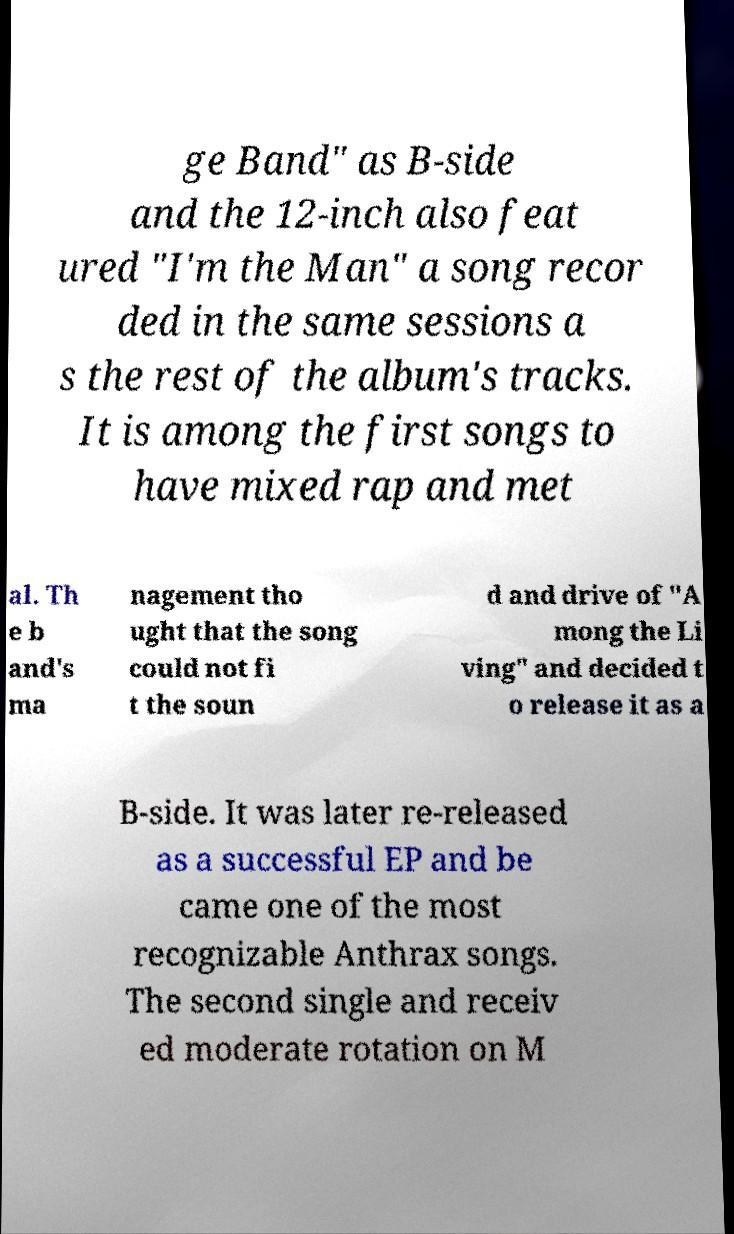Please identify and transcribe the text found in this image. ge Band" as B-side and the 12-inch also feat ured "I'm the Man" a song recor ded in the same sessions a s the rest of the album's tracks. It is among the first songs to have mixed rap and met al. Th e b and's ma nagement tho ught that the song could not fi t the soun d and drive of "A mong the Li ving" and decided t o release it as a B-side. It was later re-released as a successful EP and be came one of the most recognizable Anthrax songs. The second single and receiv ed moderate rotation on M 